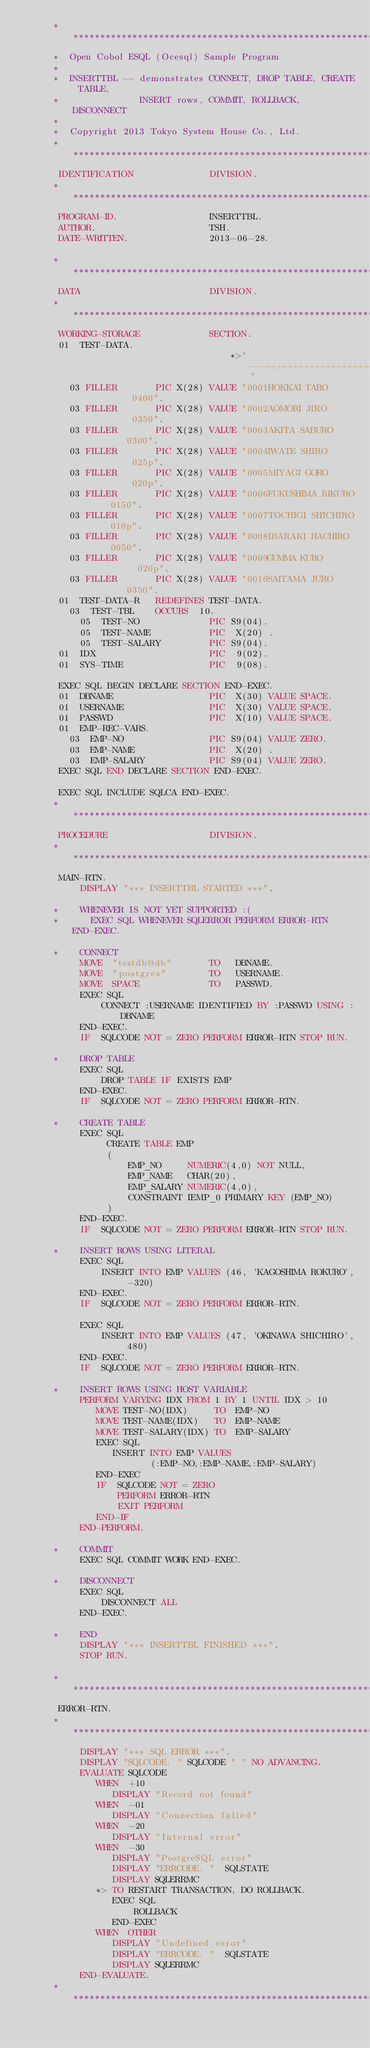Convert code to text. <code><loc_0><loc_0><loc_500><loc_500><_COBOL_>      ******************************************************************
      *  Open Cobol ESQL (Ocesql) Sample Program
      *
      *  INSERTTBL -- demonstrates CONNECT, DROP TABLE, CREATE TABLE, 
      *               INSERT rows, COMMIT, ROLLBACK, DISCONNECT
      *
      *  Copyright 2013 Tokyo System House Co., Ltd.
      ******************************************************************
       IDENTIFICATION              DIVISION.
      ******************************************************************
       PROGRAM-ID.                 INSERTTBL.
       AUTHOR.                     TSH.
       DATE-WRITTEN.               2013-06-28.

      ******************************************************************
       DATA                        DIVISION.
      ******************************************************************
       WORKING-STORAGE             SECTION.
       01  TEST-DATA.
                                       *>"---+++++++++++++++++++++----"
         03 FILLER       PIC X(28) VALUE "0001HOKKAI TARO         0400".
         03 FILLER       PIC X(28) VALUE "0002AOMORI JIRO         0350".
         03 FILLER       PIC X(28) VALUE "0003AKITA SABURO        0300".
         03 FILLER       PIC X(28) VALUE "0004IWATE SHIRO         025p".
         03 FILLER       PIC X(28) VALUE "0005MIYAGI GORO         020p".
         03 FILLER       PIC X(28) VALUE "0006FUKUSHIMA RIKURO    0150".
         03 FILLER       PIC X(28) VALUE "0007TOCHIGI SHICHIRO    010p".
         03 FILLER       PIC X(28) VALUE "0008IBARAKI HACHIRO     0050".
         03 FILLER       PIC X(28) VALUE "0009GUMMA KURO          020p".
         03 FILLER       PIC X(28) VALUE "0010SAITAMA JURO        0350".
       01  TEST-DATA-R   REDEFINES TEST-DATA.
         03  TEST-TBL    OCCURS  10.
           05  TEST-NO             PIC S9(04).
           05  TEST-NAME           PIC  X(20) .
           05  TEST-SALARY         PIC S9(04).
       01  IDX                     PIC  9(02).
       01  SYS-TIME                PIC  9(08).
 
       EXEC SQL BEGIN DECLARE SECTION END-EXEC.
       01  DBNAME                  PIC  X(30) VALUE SPACE.
       01  USERNAME                PIC  X(30) VALUE SPACE.
       01  PASSWD                  PIC  X(10) VALUE SPACE.
       01  EMP-REC-VARS.
         03  EMP-NO                PIC S9(04) VALUE ZERO.
         03  EMP-NAME              PIC  X(20) .
         03  EMP-SALARY            PIC S9(04) VALUE ZERO.
       EXEC SQL END DECLARE SECTION END-EXEC.

       EXEC SQL INCLUDE SQLCA END-EXEC.
      ******************************************************************
       PROCEDURE                   DIVISION.
      ******************************************************************
       MAIN-RTN.
           DISPLAY "*** INSERTTBL STARTED ***".

      *    WHENEVER IS NOT YET SUPPORTED :(
      *      EXEC SQL WHENEVER SQLERROR PERFORM ERROR-RTN END-EXEC.
           
      *    CONNECT
           MOVE  "testdb@db"       TO   DBNAME.
           MOVE  "postgres"        TO   USERNAME.
           MOVE  SPACE             TO   PASSWD.
           EXEC SQL
               CONNECT :USERNAME IDENTIFIED BY :PASSWD USING :DBNAME 
           END-EXEC.
           IF  SQLCODE NOT = ZERO PERFORM ERROR-RTN STOP RUN.
           
      *    DROP TABLE
           EXEC SQL
               DROP TABLE IF EXISTS EMP
           END-EXEC.
           IF  SQLCODE NOT = ZERO PERFORM ERROR-RTN.
           
      *    CREATE TABLE 
           EXEC SQL
                CREATE TABLE EMP
                (
                    EMP_NO     NUMERIC(4,0) NOT NULL,
                    EMP_NAME   CHAR(20),
                    EMP_SALARY NUMERIC(4,0),
                    CONSTRAINT IEMP_0 PRIMARY KEY (EMP_NO)
                )
           END-EXEC.
           IF  SQLCODE NOT = ZERO PERFORM ERROR-RTN STOP RUN.
           
      *    INSERT ROWS USING LITERAL
           EXEC SQL
               INSERT INTO EMP VALUES (46, 'KAGOSHIMA ROKURO', -320)
           END-EXEC.
           IF  SQLCODE NOT = ZERO PERFORM ERROR-RTN.

           EXEC SQL
               INSERT INTO EMP VALUES (47, 'OKINAWA SHICHIRO', 480)
           END-EXEC.
           IF  SQLCODE NOT = ZERO PERFORM ERROR-RTN.

      *    INSERT ROWS USING HOST VARIABLE
           PERFORM VARYING IDX FROM 1 BY 1 UNTIL IDX > 10
              MOVE TEST-NO(IDX)     TO  EMP-NO
              MOVE TEST-NAME(IDX)   TO  EMP-NAME
              MOVE TEST-SALARY(IDX) TO  EMP-SALARY
              EXEC SQL
                 INSERT INTO EMP VALUES
                        (:EMP-NO,:EMP-NAME,:EMP-SALARY)
              END-EXEC
              IF  SQLCODE NOT = ZERO 
                  PERFORM ERROR-RTN
                  EXIT PERFORM
              END-IF
           END-PERFORM.

      *    COMMIT
           EXEC SQL COMMIT WORK END-EXEC.
           
      *    DISCONNECT
           EXEC SQL
               DISCONNECT ALL
           END-EXEC.
           
      *    END
           DISPLAY "*** INSERTTBL FINISHED ***".
           STOP RUN.

      ******************************************************************
       ERROR-RTN.
      ******************************************************************
           DISPLAY "*** SQL ERROR ***".
           DISPLAY "SQLCODE: " SQLCODE " " NO ADVANCING.
           EVALUATE SQLCODE
              WHEN  +10
                 DISPLAY "Record not found"
              WHEN  -01
                 DISPLAY "Connection falied"
              WHEN  -20
                 DISPLAY "Internal error"
              WHEN  -30
                 DISPLAY "PostgreSQL error"
                 DISPLAY "ERRCODE: "  SQLSTATE
                 DISPLAY SQLERRMC
              *> TO RESTART TRANSACTION, DO ROLLBACK.
                 EXEC SQL
                     ROLLBACK
                 END-EXEC
              WHEN  OTHER
                 DISPLAY "Undefined error"
                 DISPLAY "ERRCODE: "  SQLSTATE
                 DISPLAY SQLERRMC
           END-EVALUATE.
      ******************************************************************  
</code> 